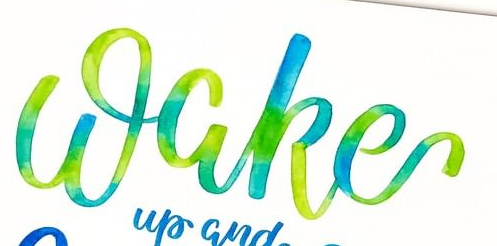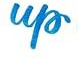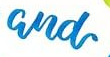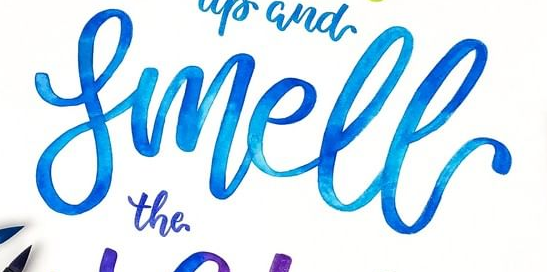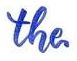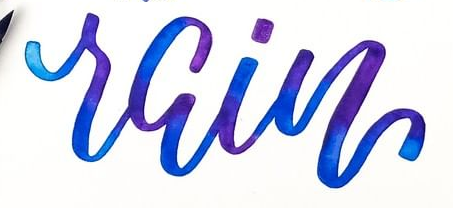What text is displayed in these images sequentially, separated by a semicolon? Wake; up; and; Smell; the; rain 